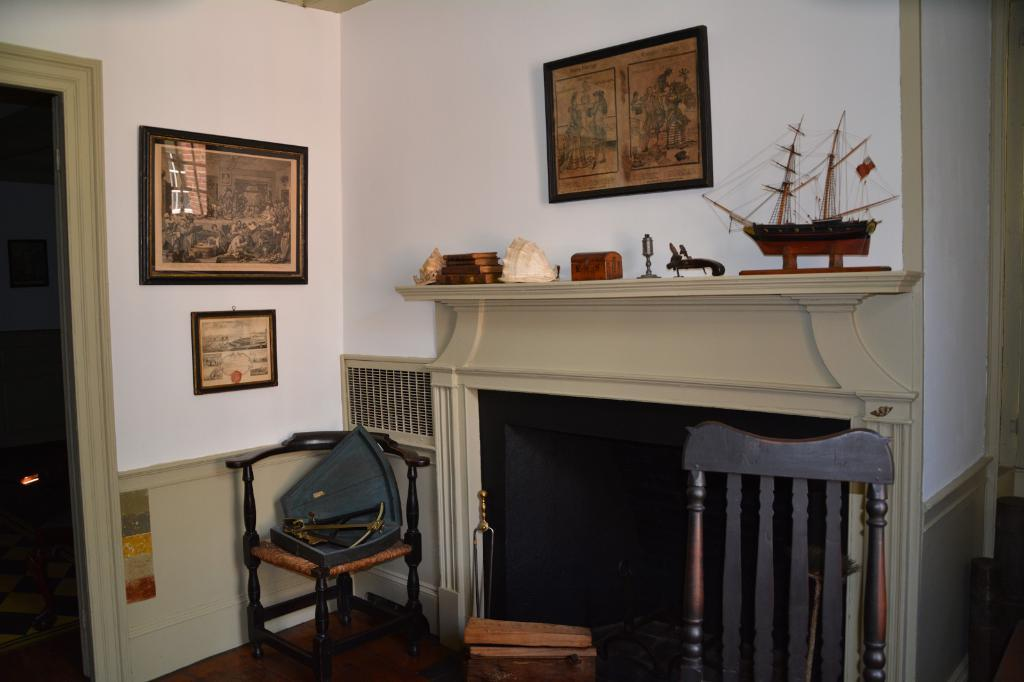What type of furniture is present in the image? There are chairs in the image. What else can be seen in the image besides the chairs? There are decorations and frames on the wall in the image. What type of goose is depicted in the story on the wall in the image? There is no story or goose present in the image; it only features chairs, decorations, and frames on the wall. 